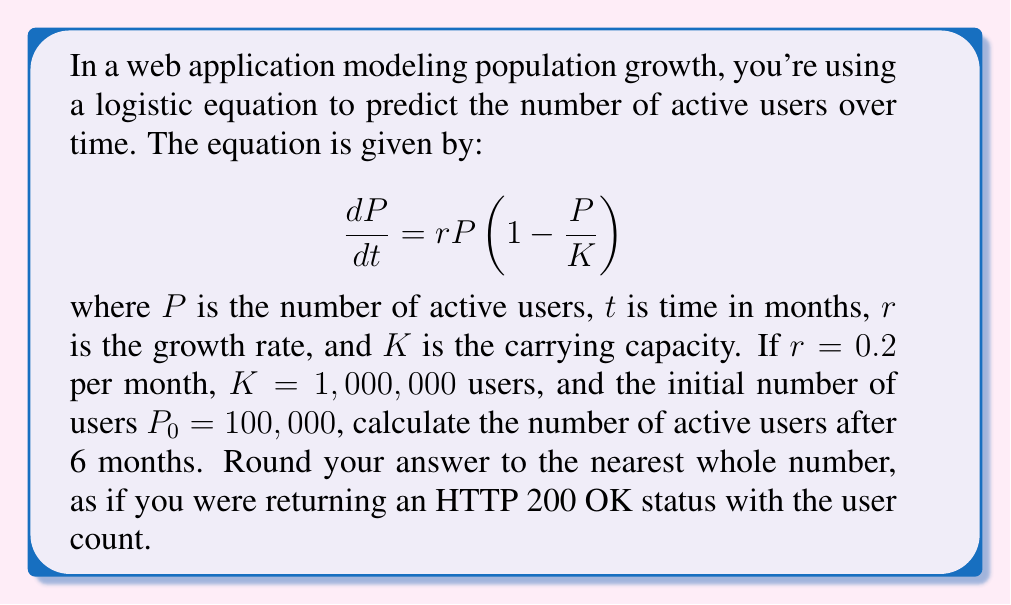Provide a solution to this math problem. To solve this problem, we need to use the solution to the logistic equation, which is given by:

$$P(t) = \frac{K}{1 + (\frac{K}{P_0} - 1)e^{-rt}}$$

Let's break down the solution step-by-step:

1. We have the following values:
   $K = 1,000,000$
   $P_0 = 100,000$
   $r = 0.2$
   $t = 6$

2. Substitute these values into the equation:

   $$P(6) = \frac{1,000,000}{1 + (\frac{1,000,000}{100,000} - 1)e^{-0.2 \cdot 6}}$$

3. Simplify the fraction inside the parentheses:

   $$P(6) = \frac{1,000,000}{1 + (10 - 1)e^{-1.2}}$$

4. Calculate $e^{-1.2}$:

   $$e^{-1.2} \approx 0.301194$$

5. Multiply $(10 - 1)$ by $e^{-1.2}$:

   $$P(6) = \frac{1,000,000}{1 + 9 \cdot 0.301194} = \frac{1,000,000}{1 + 2.710746}$$

6. Add 1 to 2.710746:

   $$P(6) = \frac{1,000,000}{3.710746}$$

7. Divide 1,000,000 by 3.710746:

   $$P(6) \approx 269,487.2$$

8. Round to the nearest whole number:

   $$P(6) \approx 269,487$$

This result represents the number of active users after 6 months, rounded to the nearest whole number as if returning an HTTP 200 OK status with the user count.
Answer: 269,487 users 